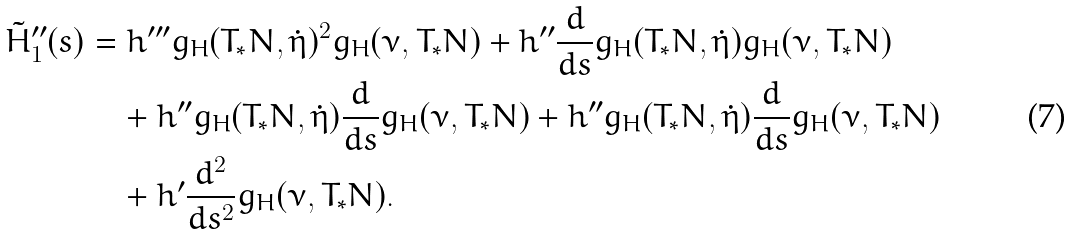<formula> <loc_0><loc_0><loc_500><loc_500>\tilde { H } ^ { \prime \prime } _ { 1 } ( s ) & = h ^ { \prime \prime \prime } g _ { H } ( T _ { * } N , \dot { \eta } ) ^ { 2 } g _ { H } ( \nu , T _ { * } N ) + h ^ { \prime \prime } \frac { d } { d s } g _ { H } ( T _ { * } N , \dot { \eta } ) g _ { H } ( \nu , T _ { * } N ) \\ & \quad + h ^ { \prime \prime } g _ { H } ( T _ { * } N , \dot { \eta } ) \frac { d } { d s } g _ { H } ( \nu , T _ { * } N ) + h ^ { \prime \prime } g _ { H } ( T _ { * } N , \dot { \eta } ) \frac { d } { d s } g _ { H } ( \nu , T _ { * } N ) \\ & \quad + h ^ { \prime } \frac { d ^ { 2 } } { d s ^ { 2 } } g _ { H } ( \nu , T _ { * } N ) .</formula> 